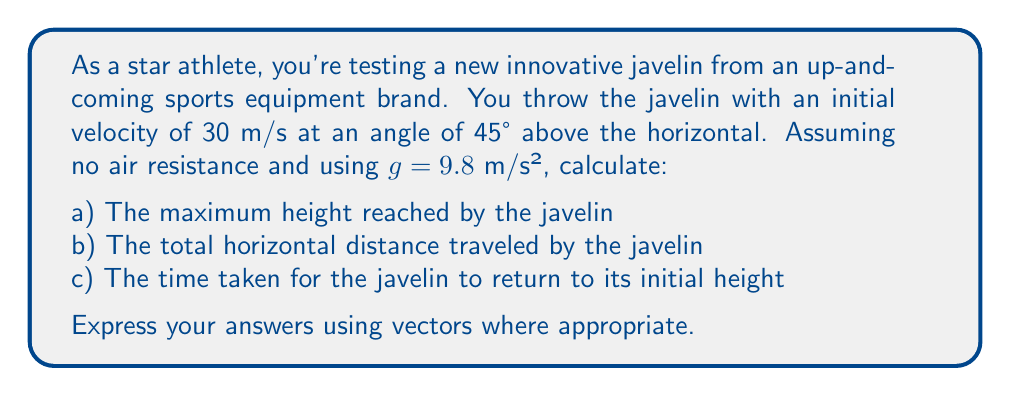Provide a solution to this math problem. Let's approach this problem step-by-step using vector components:

1) First, let's break down the initial velocity vector:
   $\vec{v_0} = (v_0 \cos \theta, v_0 \sin \theta)$
   $\vec{v_0} = (30 \cos 45°, 30 \sin 45°) = (30 \cdot \frac{\sqrt{2}}{2}, 30 \cdot \frac{\sqrt{2}}{2}) = (15\sqrt{2}, 15\sqrt{2})$ m/s

2) The acceleration due to gravity is: $\vec{g} = (0, -9.8)$ m/s²

3) The position vector as a function of time is:
   $\vec{r}(t) = \vec{r_0} + \vec{v_0}t + \frac{1}{2}\vec{g}t^2$
   $\vec{r}(t) = (0,0) + (15\sqrt{2}t, 15\sqrt{2}t) + (0, -4.9t^2)$
   $\vec{r}(t) = (15\sqrt{2}t, 15\sqrt{2}t - 4.9t^2)$

a) For maximum height, the vertical velocity component is zero:
   $v_y(t) = 15\sqrt{2} - 9.8t = 0$
   $t = \frac{15\sqrt{2}}{9.8} \approx 2.16$ s

   Substituting this time into the vertical component of $\vec{r}(t)$:
   $y_{max} = 15\sqrt{2}(2.16) - 4.9(2.16)^2 \approx 22.96$ m

b) The total horizontal distance is found when y = 0:
   $15\sqrt{2}t - 4.9t^2 = 0$
   $t(15\sqrt{2} - 4.9t) = 0$
   $t = 0$ or $t = \frac{15\sqrt{2}}{4.9} \approx 4.32$ s

   The horizontal distance is:
   $x = 15\sqrt{2}(4.32) \approx 91.84$ m

c) The time taken is the same as found in part b: 4.32 s

The trajectory vector can be expressed as:
$\vec{r}(t) = (15\sqrt{2}t, 15\sqrt{2}t - 4.9t^2)$ for $0 \leq t \leq 4.32$
Answer: a) Maximum height: 22.96 m
b) Total horizontal distance: 91.84 m
c) Time taken: 4.32 s
Trajectory vector: $\vec{r}(t) = (15\sqrt{2}t, 15\sqrt{2}t - 4.9t^2)$ for $0 \leq t \leq 4.32$ 